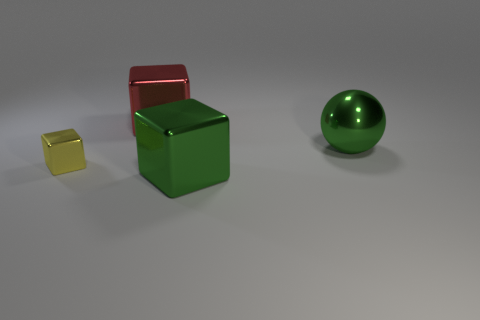Subtract 1 cubes. How many cubes are left? 2 Add 3 big red metal cubes. How many objects exist? 7 Subtract all cubes. How many objects are left? 1 Subtract all blue shiny objects. Subtract all green metallic blocks. How many objects are left? 3 Add 3 large green metallic objects. How many large green metallic objects are left? 5 Add 2 big green shiny objects. How many big green shiny objects exist? 4 Subtract 0 blue cylinders. How many objects are left? 4 